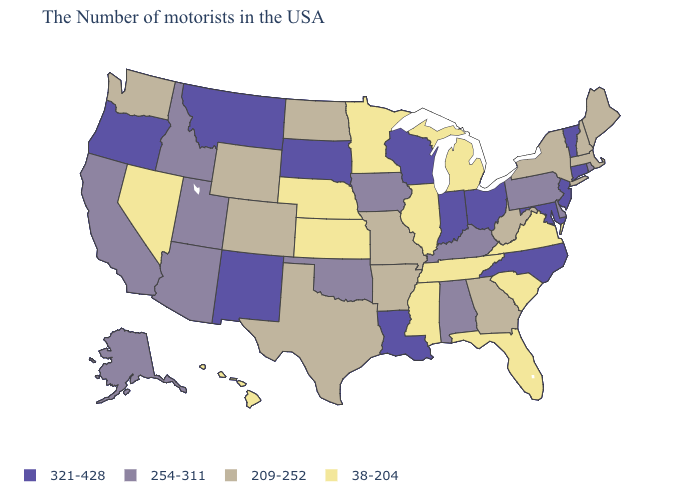Name the states that have a value in the range 254-311?
Short answer required. Rhode Island, Delaware, Pennsylvania, Kentucky, Alabama, Iowa, Oklahoma, Utah, Arizona, Idaho, California, Alaska. Does the first symbol in the legend represent the smallest category?
Be succinct. No. What is the lowest value in states that border Connecticut?
Write a very short answer. 209-252. Is the legend a continuous bar?
Write a very short answer. No. Which states hav the highest value in the MidWest?
Short answer required. Ohio, Indiana, Wisconsin, South Dakota. Does the map have missing data?
Concise answer only. No. Which states hav the highest value in the West?
Concise answer only. New Mexico, Montana, Oregon. Is the legend a continuous bar?
Keep it brief. No. What is the value of New Hampshire?
Keep it brief. 209-252. Name the states that have a value in the range 38-204?
Answer briefly. Virginia, South Carolina, Florida, Michigan, Tennessee, Illinois, Mississippi, Minnesota, Kansas, Nebraska, Nevada, Hawaii. What is the value of Georgia?
Be succinct. 209-252. Does Delaware have the same value as California?
Be succinct. Yes. Does Wyoming have the lowest value in the West?
Give a very brief answer. No. What is the value of Massachusetts?
Write a very short answer. 209-252. 